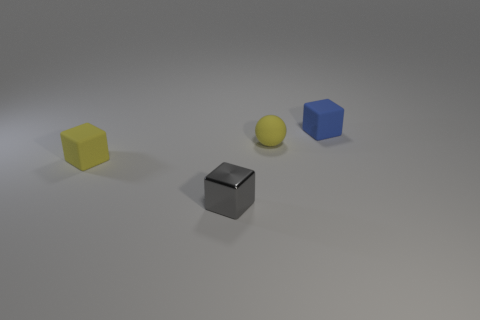Add 2 tiny blue rubber objects. How many objects exist? 6 Subtract all balls. How many objects are left? 3 Add 4 small gray metal things. How many small gray metal things are left? 5 Add 1 large purple metallic balls. How many large purple metallic balls exist? 1 Subtract 0 purple balls. How many objects are left? 4 Subtract all shiny spheres. Subtract all small blue cubes. How many objects are left? 3 